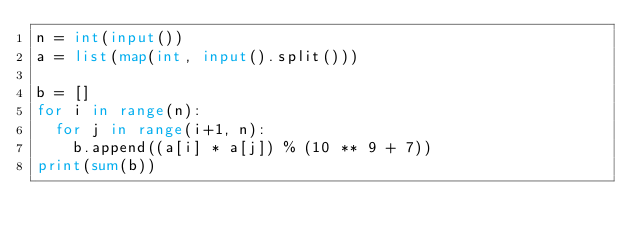<code> <loc_0><loc_0><loc_500><loc_500><_Python_>n = int(input())
a = list(map(int, input().split()))

b = []
for i in range(n):
  for j in range(i+1, n):
    b.append((a[i] * a[j]) % (10 ** 9 + 7))
print(sum(b))</code> 